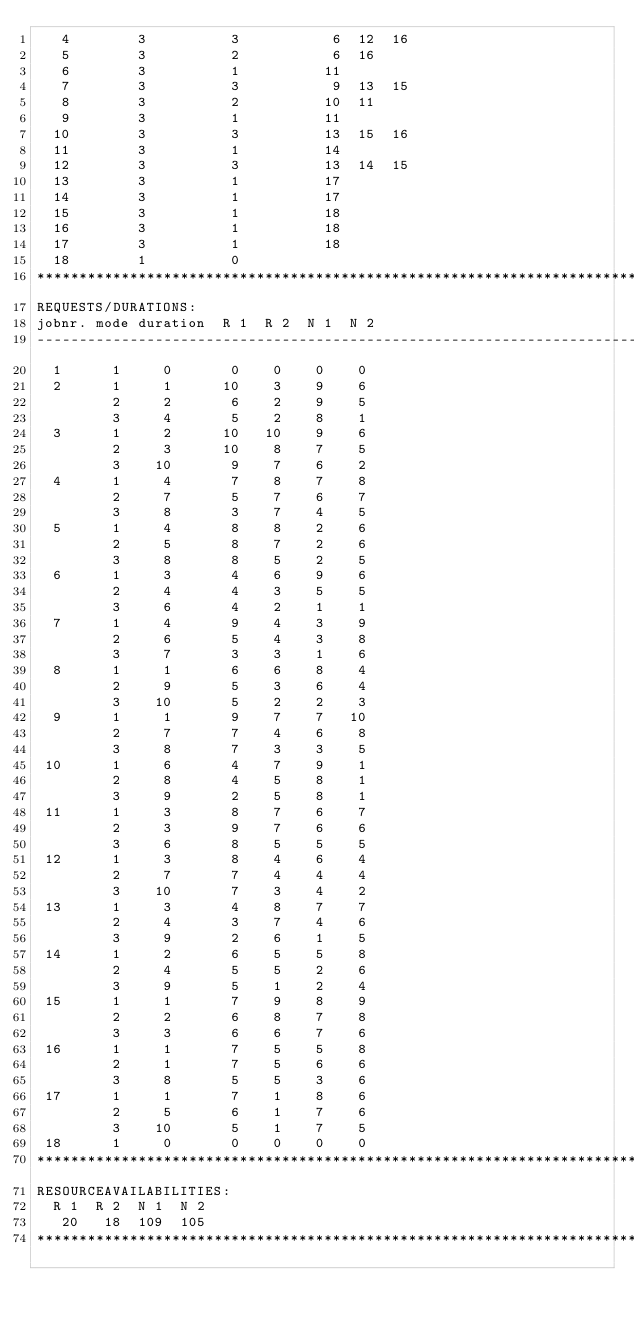Convert code to text. <code><loc_0><loc_0><loc_500><loc_500><_ObjectiveC_>   4        3          3           6  12  16
   5        3          2           6  16
   6        3          1          11
   7        3          3           9  13  15
   8        3          2          10  11
   9        3          1          11
  10        3          3          13  15  16
  11        3          1          14
  12        3          3          13  14  15
  13        3          1          17
  14        3          1          17
  15        3          1          18
  16        3          1          18
  17        3          1          18
  18        1          0        
************************************************************************
REQUESTS/DURATIONS:
jobnr. mode duration  R 1  R 2  N 1  N 2
------------------------------------------------------------------------
  1      1     0       0    0    0    0
  2      1     1      10    3    9    6
         2     2       6    2    9    5
         3     4       5    2    8    1
  3      1     2      10   10    9    6
         2     3      10    8    7    5
         3    10       9    7    6    2
  4      1     4       7    8    7    8
         2     7       5    7    6    7
         3     8       3    7    4    5
  5      1     4       8    8    2    6
         2     5       8    7    2    6
         3     8       8    5    2    5
  6      1     3       4    6    9    6
         2     4       4    3    5    5
         3     6       4    2    1    1
  7      1     4       9    4    3    9
         2     6       5    4    3    8
         3     7       3    3    1    6
  8      1     1       6    6    8    4
         2     9       5    3    6    4
         3    10       5    2    2    3
  9      1     1       9    7    7   10
         2     7       7    4    6    8
         3     8       7    3    3    5
 10      1     6       4    7    9    1
         2     8       4    5    8    1
         3     9       2    5    8    1
 11      1     3       8    7    6    7
         2     3       9    7    6    6
         3     6       8    5    5    5
 12      1     3       8    4    6    4
         2     7       7    4    4    4
         3    10       7    3    4    2
 13      1     3       4    8    7    7
         2     4       3    7    4    6
         3     9       2    6    1    5
 14      1     2       6    5    5    8
         2     4       5    5    2    6
         3     9       5    1    2    4
 15      1     1       7    9    8    9
         2     2       6    8    7    8
         3     3       6    6    7    6
 16      1     1       7    5    5    8
         2     1       7    5    6    6
         3     8       5    5    3    6
 17      1     1       7    1    8    6
         2     5       6    1    7    6
         3    10       5    1    7    5
 18      1     0       0    0    0    0
************************************************************************
RESOURCEAVAILABILITIES:
  R 1  R 2  N 1  N 2
   20   18  109  105
************************************************************************
</code> 